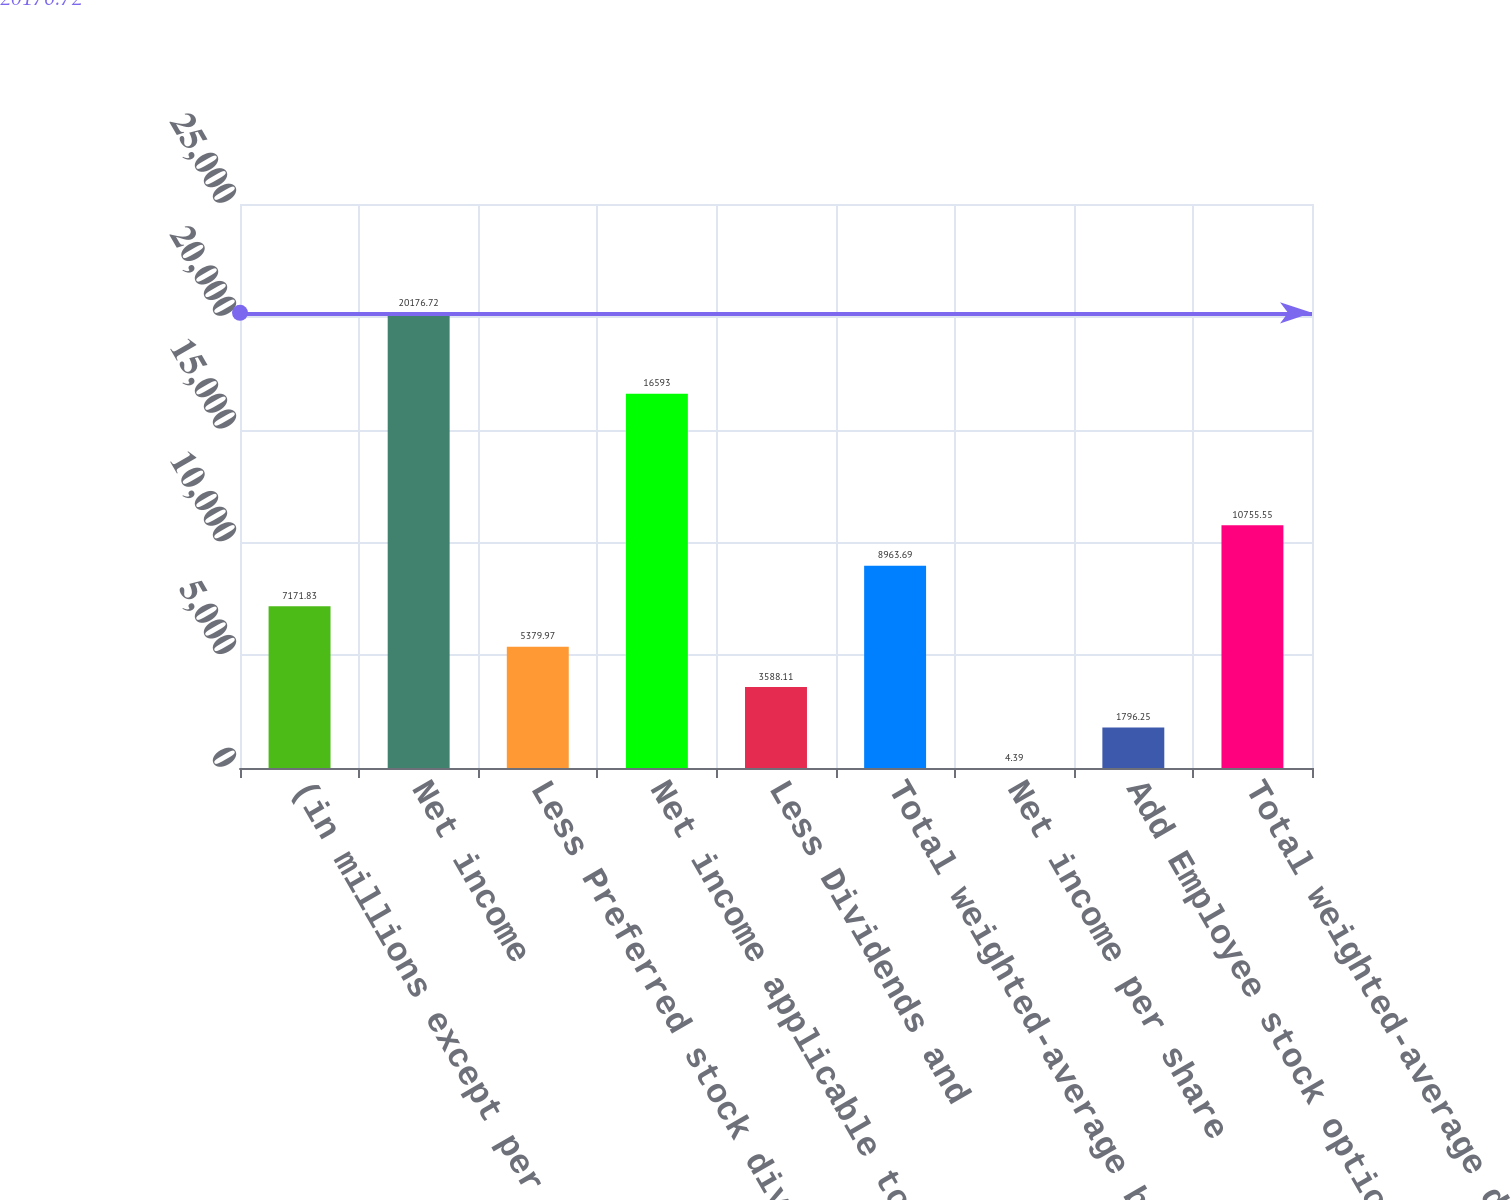<chart> <loc_0><loc_0><loc_500><loc_500><bar_chart><fcel>(in millions except per share<fcel>Net income<fcel>Less Preferred stock dividends<fcel>Net income applicable to<fcel>Less Dividends and<fcel>Total weighted-average basic<fcel>Net income per share<fcel>Add Employee stock options<fcel>Total weighted-average diluted<nl><fcel>7171.83<fcel>20176.7<fcel>5379.97<fcel>16593<fcel>3588.11<fcel>8963.69<fcel>4.39<fcel>1796.25<fcel>10755.5<nl></chart> 